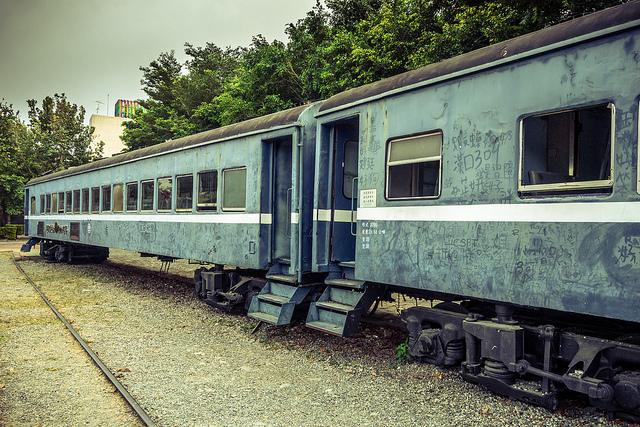What is on the other side of the train?
Quick response, please. Trees. Is this a modern train?
Short answer required. No. What color is the stripe on the train?
Answer briefly. White. 